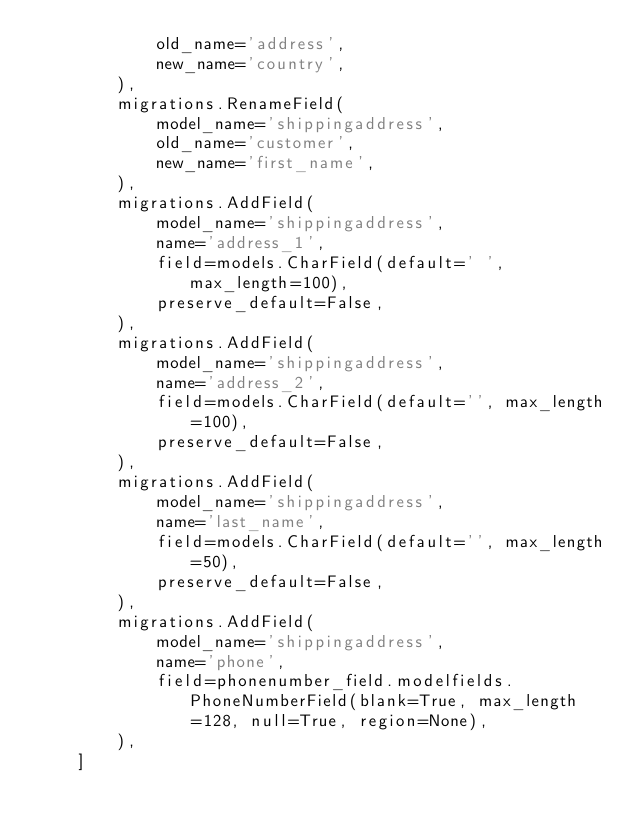<code> <loc_0><loc_0><loc_500><loc_500><_Python_>            old_name='address',
            new_name='country',
        ),
        migrations.RenameField(
            model_name='shippingaddress',
            old_name='customer',
            new_name='first_name',
        ),
        migrations.AddField(
            model_name='shippingaddress',
            name='address_1',
            field=models.CharField(default=' ', max_length=100),
            preserve_default=False,
        ),
        migrations.AddField(
            model_name='shippingaddress',
            name='address_2',
            field=models.CharField(default='', max_length=100),
            preserve_default=False,
        ),
        migrations.AddField(
            model_name='shippingaddress',
            name='last_name',
            field=models.CharField(default='', max_length=50),
            preserve_default=False,
        ),
        migrations.AddField(
            model_name='shippingaddress',
            name='phone',
            field=phonenumber_field.modelfields.PhoneNumberField(blank=True, max_length=128, null=True, region=None),
        ),
    ]
</code> 